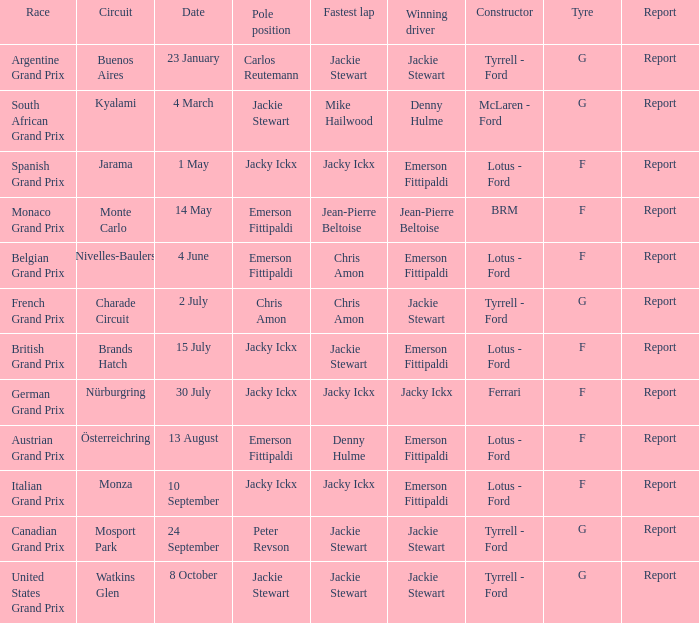When did the argentine grand prix take place? 23 January. 